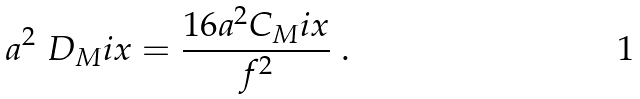Convert formula to latex. <formula><loc_0><loc_0><loc_500><loc_500>a ^ { 2 } \ D _ { M } i x = \frac { 1 6 a ^ { 2 } C _ { M } i x } { f ^ { 2 } } \ .</formula> 